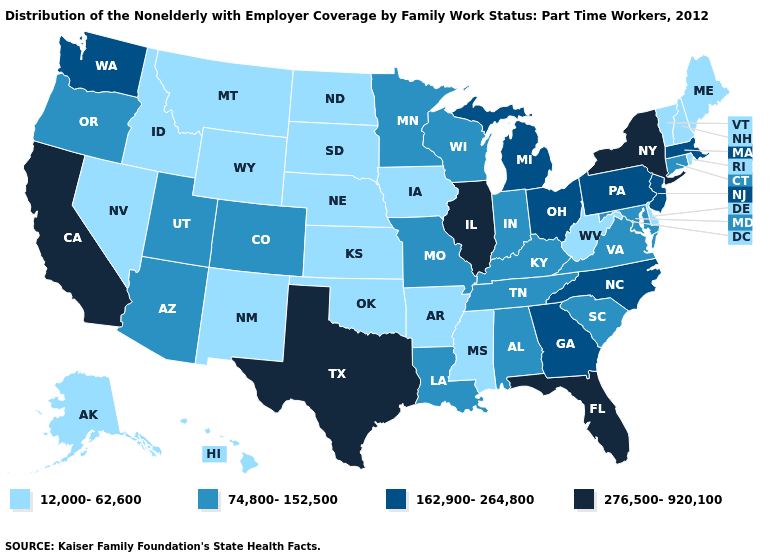What is the highest value in the USA?
Write a very short answer. 276,500-920,100. Name the states that have a value in the range 12,000-62,600?
Give a very brief answer. Alaska, Arkansas, Delaware, Hawaii, Idaho, Iowa, Kansas, Maine, Mississippi, Montana, Nebraska, Nevada, New Hampshire, New Mexico, North Dakota, Oklahoma, Rhode Island, South Dakota, Vermont, West Virginia, Wyoming. Does Utah have a lower value than Arizona?
Write a very short answer. No. Does Oklahoma have the same value as Iowa?
Be succinct. Yes. What is the value of Alaska?
Concise answer only. 12,000-62,600. What is the lowest value in the MidWest?
Write a very short answer. 12,000-62,600. What is the value of Vermont?
Concise answer only. 12,000-62,600. Among the states that border Michigan , which have the lowest value?
Quick response, please. Indiana, Wisconsin. What is the value of Idaho?
Quick response, please. 12,000-62,600. Does New York have the highest value in the Northeast?
Answer briefly. Yes. Does Kentucky have a higher value than Hawaii?
Answer briefly. Yes. What is the value of South Carolina?
Short answer required. 74,800-152,500. Name the states that have a value in the range 12,000-62,600?
Answer briefly. Alaska, Arkansas, Delaware, Hawaii, Idaho, Iowa, Kansas, Maine, Mississippi, Montana, Nebraska, Nevada, New Hampshire, New Mexico, North Dakota, Oklahoma, Rhode Island, South Dakota, Vermont, West Virginia, Wyoming. Does New York have the same value as Wyoming?
Keep it brief. No. Name the states that have a value in the range 12,000-62,600?
Write a very short answer. Alaska, Arkansas, Delaware, Hawaii, Idaho, Iowa, Kansas, Maine, Mississippi, Montana, Nebraska, Nevada, New Hampshire, New Mexico, North Dakota, Oklahoma, Rhode Island, South Dakota, Vermont, West Virginia, Wyoming. 